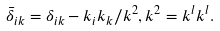Convert formula to latex. <formula><loc_0><loc_0><loc_500><loc_500>\bar { \delta } _ { i k } = \delta _ { i k } - k _ { i } k _ { k } / k ^ { 2 } , k ^ { 2 } = k ^ { l } k ^ { l } .</formula> 